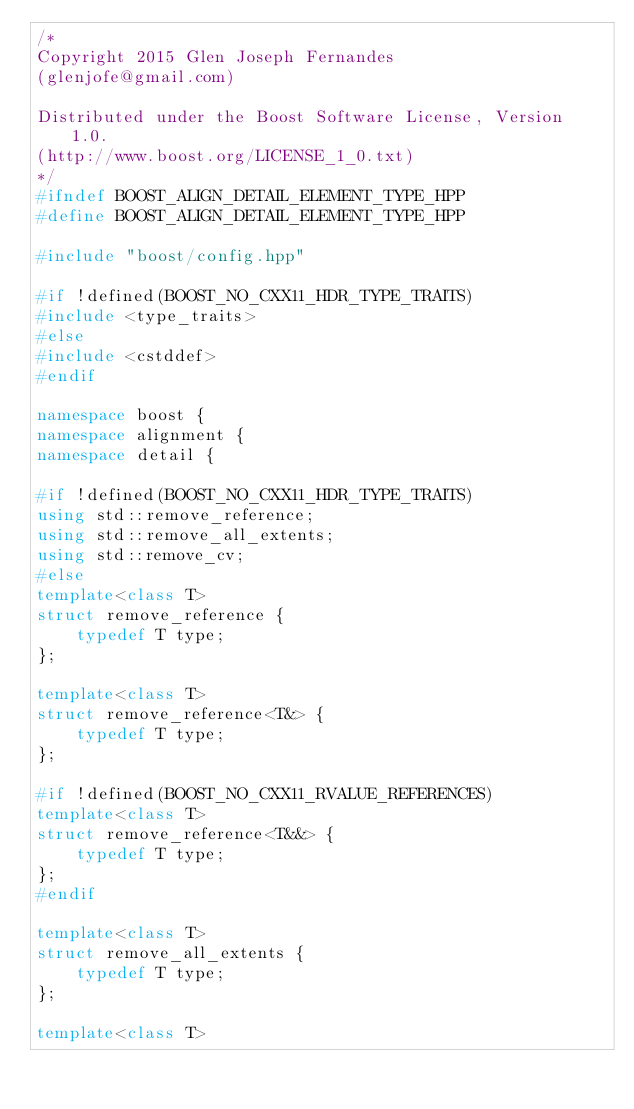Convert code to text. <code><loc_0><loc_0><loc_500><loc_500><_C++_>/*
Copyright 2015 Glen Joseph Fernandes
(glenjofe@gmail.com)

Distributed under the Boost Software License, Version 1.0.
(http://www.boost.org/LICENSE_1_0.txt)
*/
#ifndef BOOST_ALIGN_DETAIL_ELEMENT_TYPE_HPP
#define BOOST_ALIGN_DETAIL_ELEMENT_TYPE_HPP

#include "boost/config.hpp"

#if !defined(BOOST_NO_CXX11_HDR_TYPE_TRAITS)
#include <type_traits>
#else
#include <cstddef>
#endif

namespace boost {
namespace alignment {
namespace detail {

#if !defined(BOOST_NO_CXX11_HDR_TYPE_TRAITS)
using std::remove_reference;
using std::remove_all_extents;
using std::remove_cv;
#else
template<class T>
struct remove_reference {
    typedef T type;
};

template<class T>
struct remove_reference<T&> {
    typedef T type;
};

#if !defined(BOOST_NO_CXX11_RVALUE_REFERENCES)
template<class T>
struct remove_reference<T&&> {
    typedef T type;
};
#endif

template<class T>
struct remove_all_extents {
    typedef T type;
};

template<class T></code> 